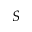Convert formula to latex. <formula><loc_0><loc_0><loc_500><loc_500>S</formula> 